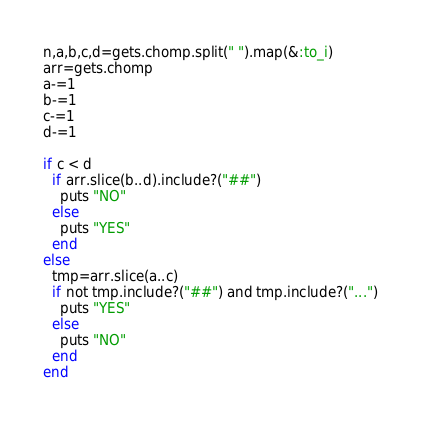<code> <loc_0><loc_0><loc_500><loc_500><_Ruby_>n,a,b,c,d=gets.chomp.split(" ").map(&:to_i)
arr=gets.chomp
a-=1
b-=1
c-=1
d-=1

if c < d
  if arr.slice(b..d).include?("##")
    puts "NO"
  else
    puts "YES"
  end
else
  tmp=arr.slice(a..c)
  if not tmp.include?("##") and tmp.include?("...")
    puts "YES"
  else
    puts "NO"
  end
end</code> 